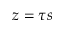Convert formula to latex. <formula><loc_0><loc_0><loc_500><loc_500>z = \tau s</formula> 